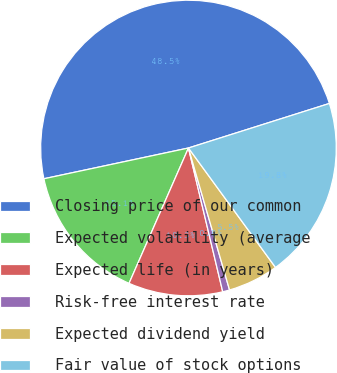<chart> <loc_0><loc_0><loc_500><loc_500><pie_chart><fcel>Closing price of our common<fcel>Expected volatility (average<fcel>Expected life (in years)<fcel>Risk-free interest rate<fcel>Expected dividend yield<fcel>Fair value of stock options<nl><fcel>48.47%<fcel>15.08%<fcel>10.31%<fcel>0.76%<fcel>5.54%<fcel>19.85%<nl></chart> 